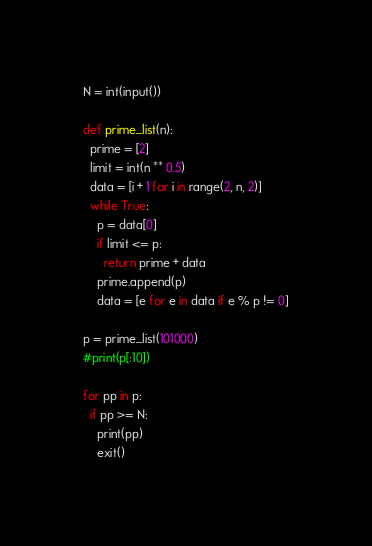<code> <loc_0><loc_0><loc_500><loc_500><_Python_>N = int(input())

def prime_list(n):
  prime = [2]
  limit = int(n ** 0.5)
  data = [i + 1 for i in range(2, n, 2)]
  while True:
    p = data[0]
    if limit <= p:
      return prime + data
    prime.append(p)
    data = [e for e in data if e % p != 0]
    
p = prime_list(101000)
#print(p[:10])

for pp in p:
  if pp >= N:
    print(pp)
    exit()</code> 